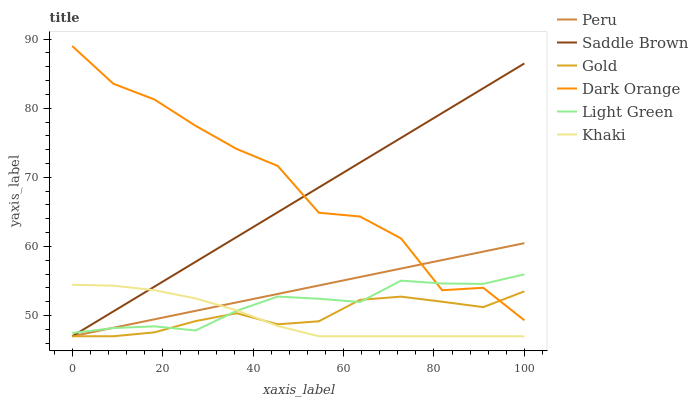Does Khaki have the minimum area under the curve?
Answer yes or no. Yes. Does Dark Orange have the maximum area under the curve?
Answer yes or no. Yes. Does Peru have the minimum area under the curve?
Answer yes or no. No. Does Peru have the maximum area under the curve?
Answer yes or no. No. Is Peru the smoothest?
Answer yes or no. Yes. Is Dark Orange the roughest?
Answer yes or no. Yes. Is Khaki the smoothest?
Answer yes or no. No. Is Khaki the roughest?
Answer yes or no. No. Does Khaki have the lowest value?
Answer yes or no. Yes. Does Light Green have the lowest value?
Answer yes or no. No. Does Dark Orange have the highest value?
Answer yes or no. Yes. Does Khaki have the highest value?
Answer yes or no. No. Is Khaki less than Dark Orange?
Answer yes or no. Yes. Is Dark Orange greater than Khaki?
Answer yes or no. Yes. Does Peru intersect Light Green?
Answer yes or no. Yes. Is Peru less than Light Green?
Answer yes or no. No. Is Peru greater than Light Green?
Answer yes or no. No. Does Khaki intersect Dark Orange?
Answer yes or no. No. 